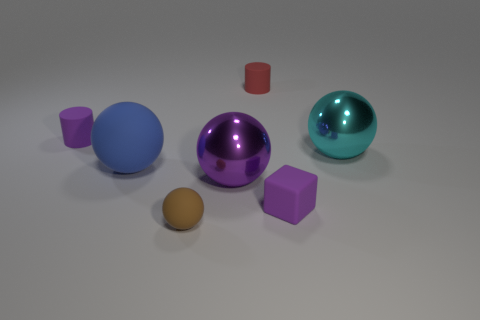Subtract all brown spheres. Subtract all cyan cubes. How many spheres are left? 3 Add 2 brown rubber things. How many objects exist? 9 Subtract all cylinders. How many objects are left? 5 Subtract all small purple rubber objects. Subtract all big yellow matte spheres. How many objects are left? 5 Add 1 blue matte balls. How many blue matte balls are left? 2 Add 5 big metallic spheres. How many big metallic spheres exist? 7 Subtract 0 yellow cubes. How many objects are left? 7 